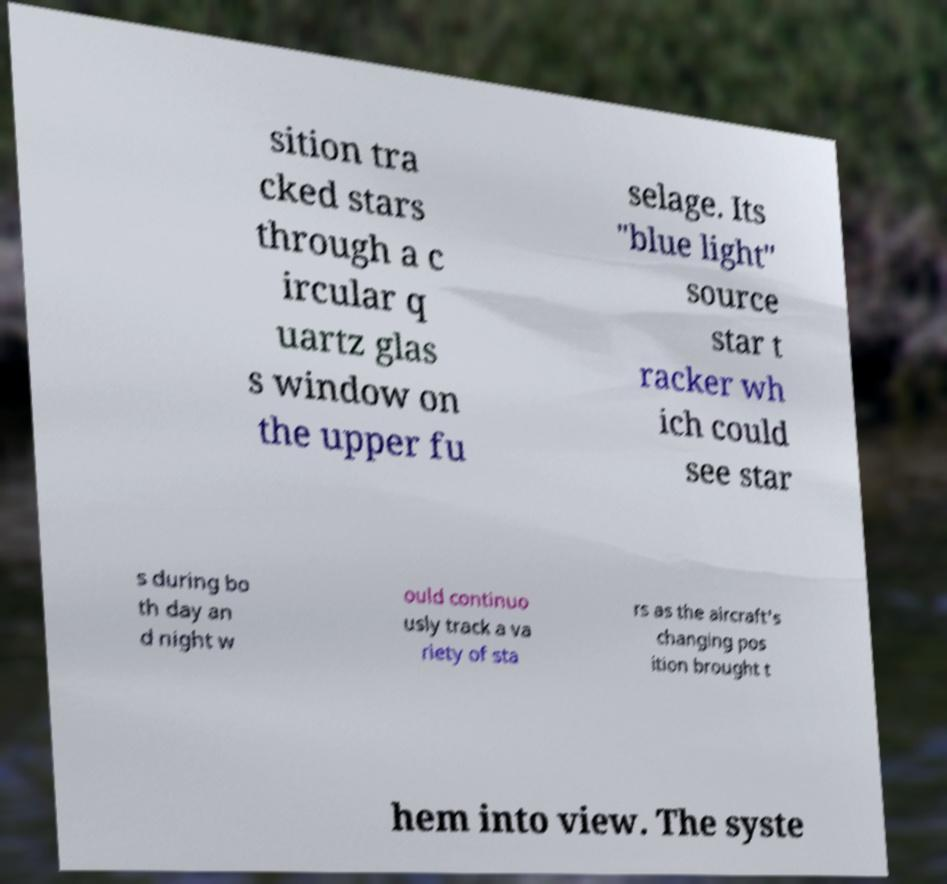Could you assist in decoding the text presented in this image and type it out clearly? sition tra cked stars through a c ircular q uartz glas s window on the upper fu selage. Its "blue light" source star t racker wh ich could see star s during bo th day an d night w ould continuo usly track a va riety of sta rs as the aircraft's changing pos ition brought t hem into view. The syste 